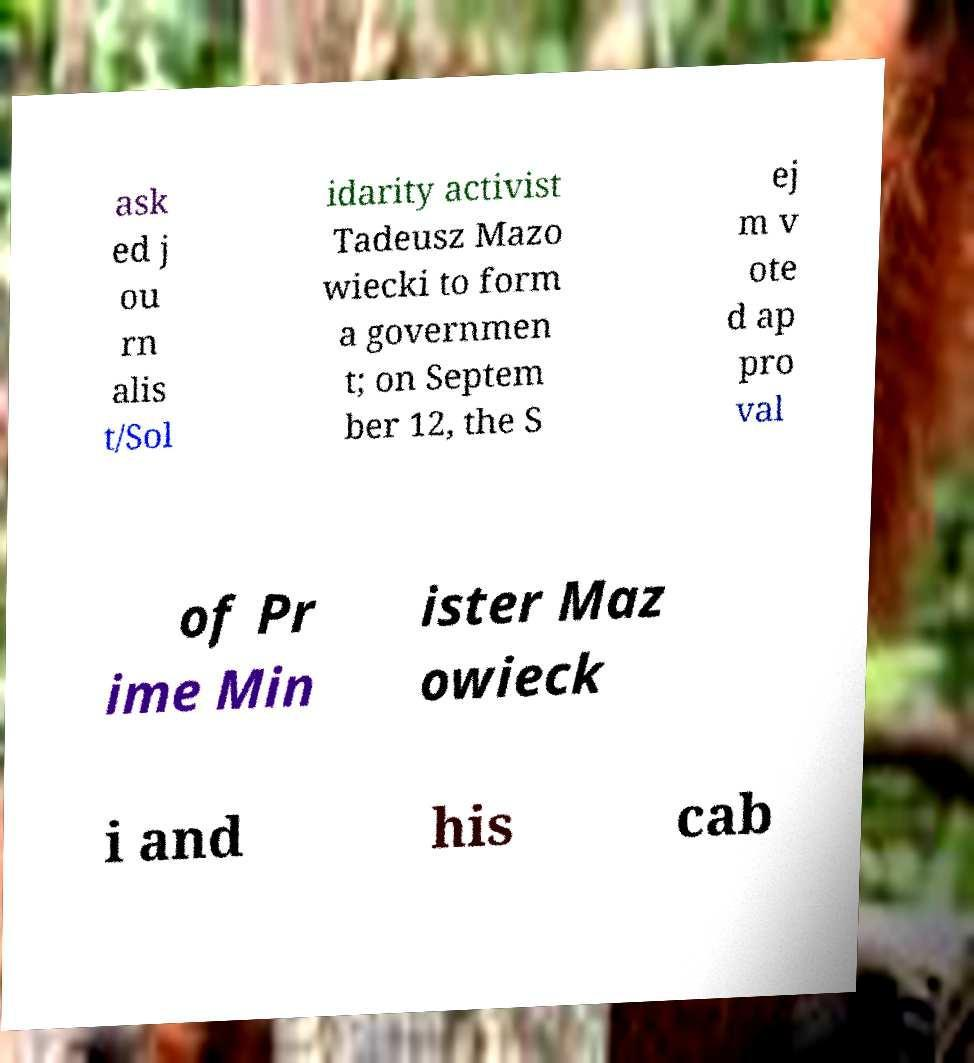Can you accurately transcribe the text from the provided image for me? ask ed j ou rn alis t/Sol idarity activist Tadeusz Mazo wiecki to form a governmen t; on Septem ber 12, the S ej m v ote d ap pro val of Pr ime Min ister Maz owieck i and his cab 